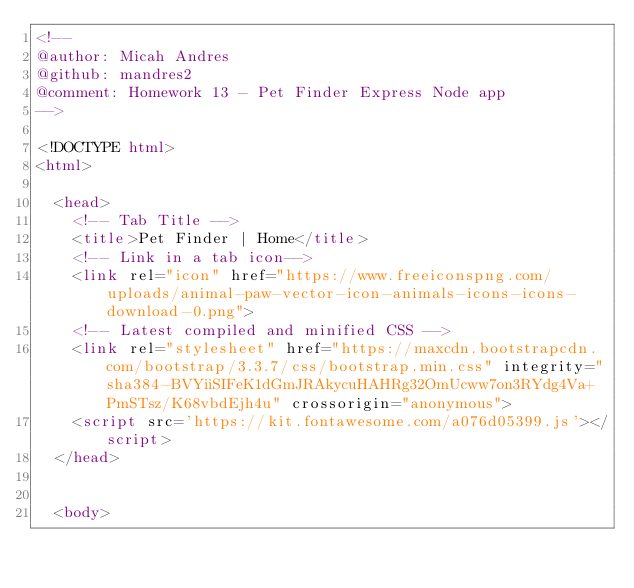Convert code to text. <code><loc_0><loc_0><loc_500><loc_500><_HTML_><!--
@author: Micah Andres
@github: mandres2
@comment: Homework 13 - Pet Finder Express Node app
-->

<!DOCTYPE html>
<html>

  <head>
    <!-- Tab Title -->
    <title>Pet Finder | Home</title>
    <!-- Link in a tab icon-->
    <link rel="icon" href="https://www.freeiconspng.com/uploads/animal-paw-vector-icon-animals-icons-icons-download-0.png">
    <!-- Latest compiled and minified CSS -->
    <link rel="stylesheet" href="https://maxcdn.bootstrapcdn.com/bootstrap/3.3.7/css/bootstrap.min.css" integrity="sha384-BVYiiSIFeK1dGmJRAkycuHAHRg32OmUcww7on3RYdg4Va+PmSTsz/K68vbdEjh4u" crossorigin="anonymous">
    <script src='https://kit.fontawesome.com/a076d05399.js'></script>
  </head>


  <body>
</code> 